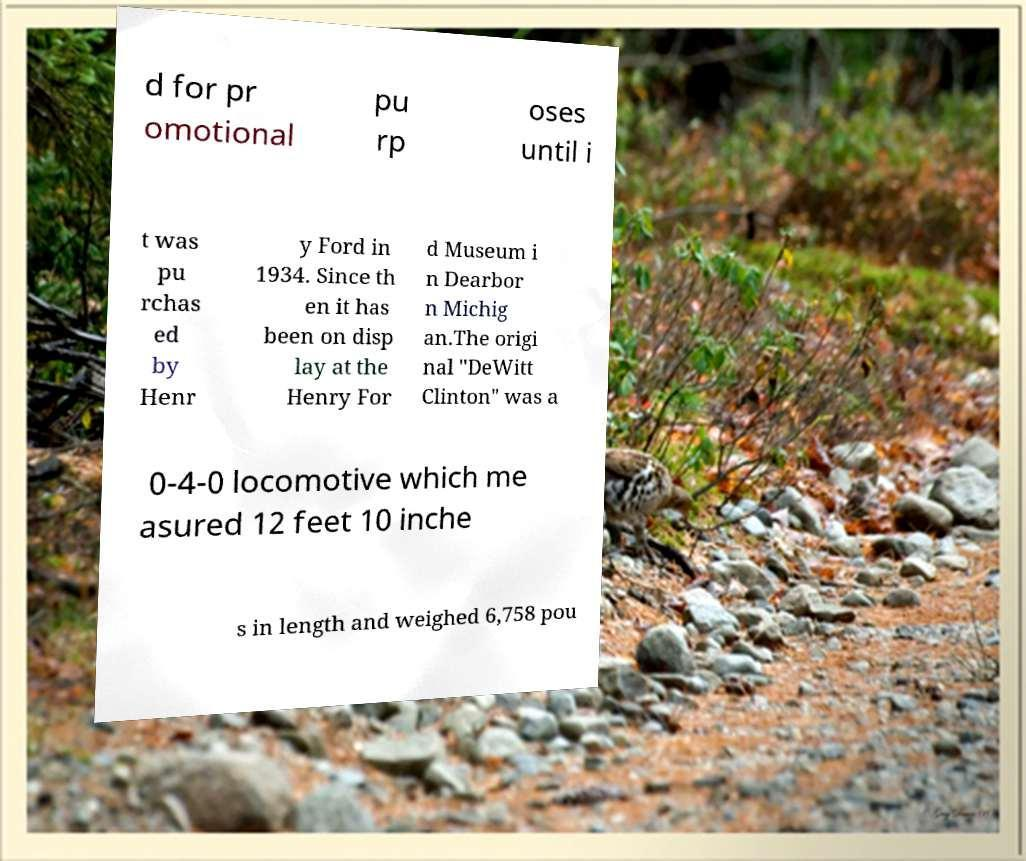There's text embedded in this image that I need extracted. Can you transcribe it verbatim? d for pr omotional pu rp oses until i t was pu rchas ed by Henr y Ford in 1934. Since th en it has been on disp lay at the Henry For d Museum i n Dearbor n Michig an.The origi nal "DeWitt Clinton" was a 0-4-0 locomotive which me asured 12 feet 10 inche s in length and weighed 6,758 pou 